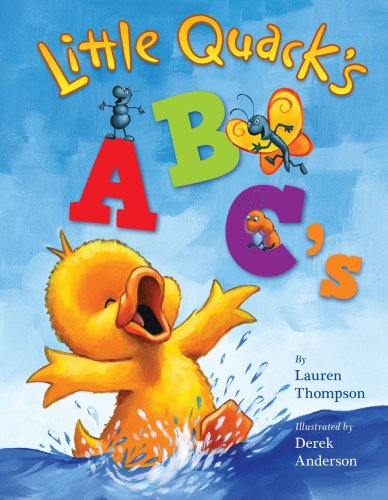Can you describe the main character seen on this book's cover? The main character on the cover of 'Little Quack's ABC's' is Little Quack the duckling. He appears very joyful and animated, splashing in the water. 